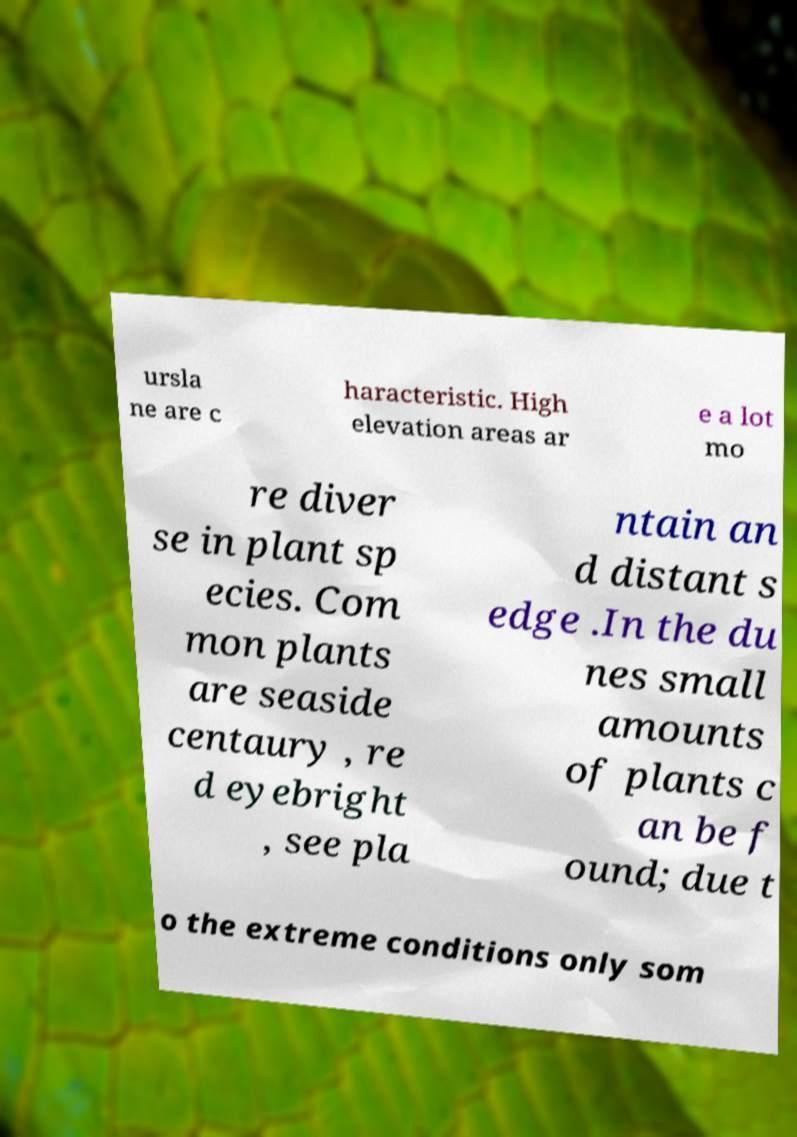Please identify and transcribe the text found in this image. ursla ne are c haracteristic. High elevation areas ar e a lot mo re diver se in plant sp ecies. Com mon plants are seaside centaury , re d eyebright , see pla ntain an d distant s edge .In the du nes small amounts of plants c an be f ound; due t o the extreme conditions only som 